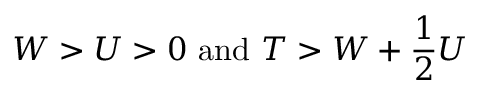Convert formula to latex. <formula><loc_0><loc_0><loc_500><loc_500>W > U > 0 a n d T > W + \frac { 1 } { 2 } U</formula> 